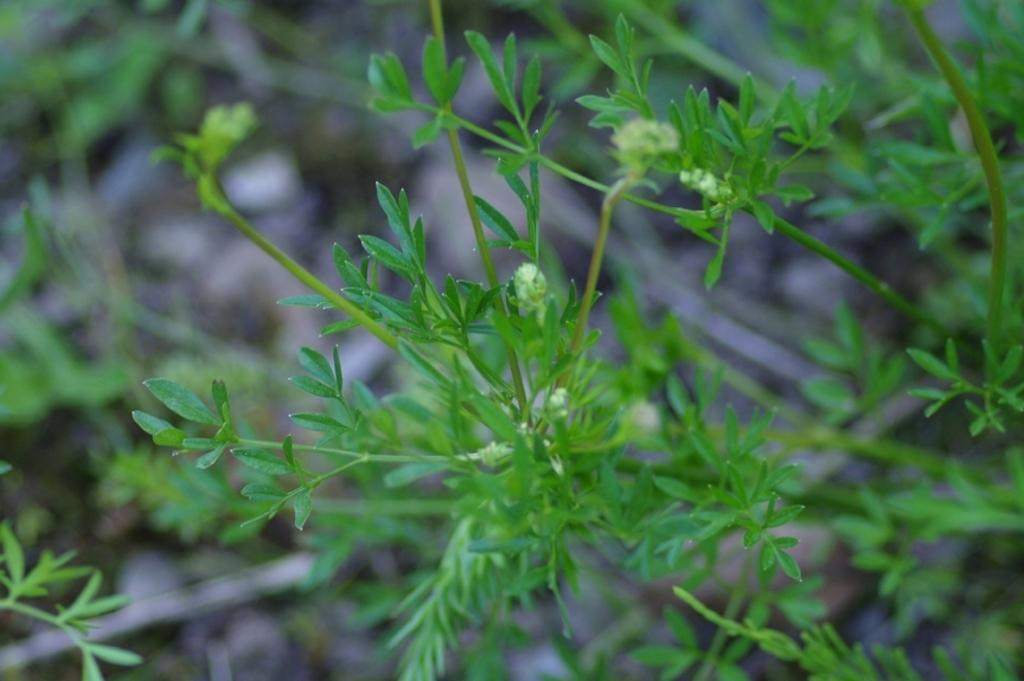What type of living organisms can be seen in the image? Plants can be seen in the image. Can you describe the background of the image? The background of the image is blurred. What type of engine can be seen in the image? There is no engine present in the image; it features plants and a blurred background. How many people are sneezing in the image? There are no people present in the image, so it is not possible to determine if anyone is sneezing. 